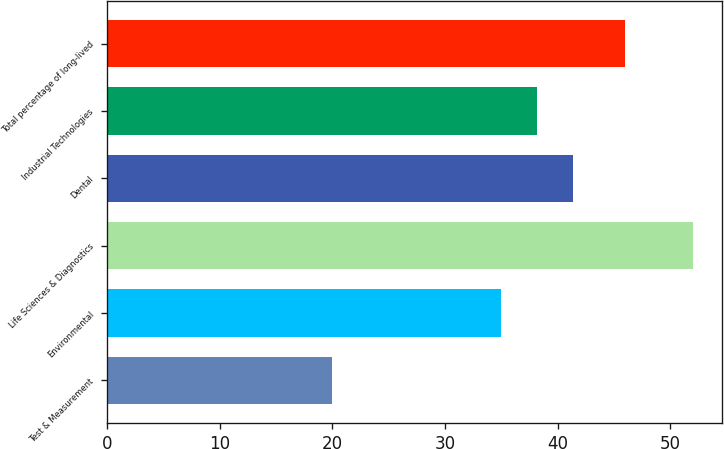<chart> <loc_0><loc_0><loc_500><loc_500><bar_chart><fcel>Test & Measurement<fcel>Environmental<fcel>Life Sciences & Diagnostics<fcel>Dental<fcel>Industrial Technologies<fcel>Total percentage of long-lived<nl><fcel>20<fcel>35<fcel>52<fcel>41.4<fcel>38.2<fcel>46<nl></chart> 